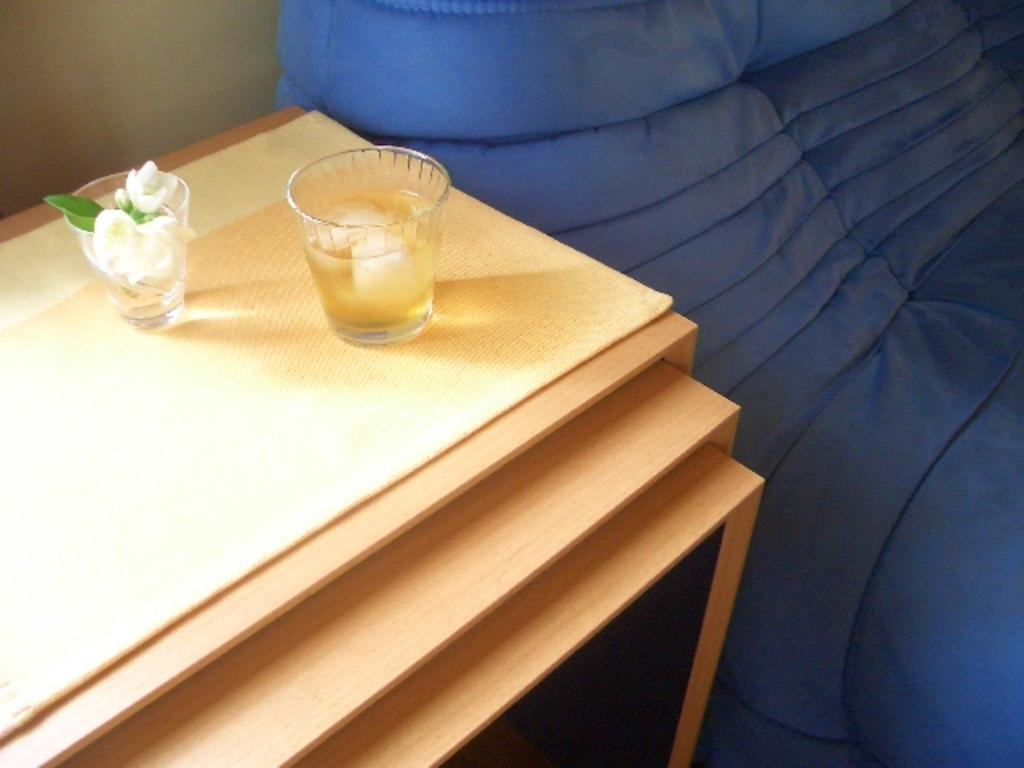What object is visible in the image that is typically used for drinking? There is a glass in the image that is typically used for drinking. What type of decorative item can be seen in the image? There are flowers in the image, which are often used as decorative items. Where are the glass and flowers located in the image? Both the glass and flowers are on a table in the image. What type of trade is being conducted in the image? There is no indication of any trade being conducted in the image; it features a glass and flowers on a table. Can you tell me the color of the aunt's eye in the image? There is no aunt present in the image, so it is not possible to determine the color of their eye. 